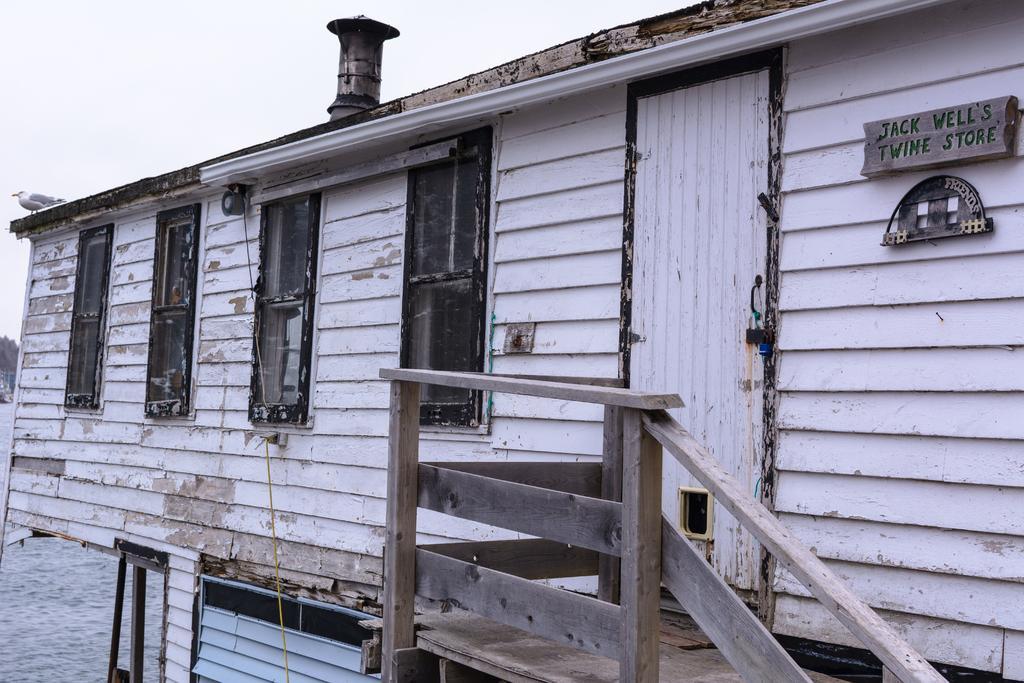Please provide a concise description of this image. In this image we can see wooden stairs, wooden house on which we can see a board and a bird. In the background, we can see the sky. Here we can see the snow on the ground. 